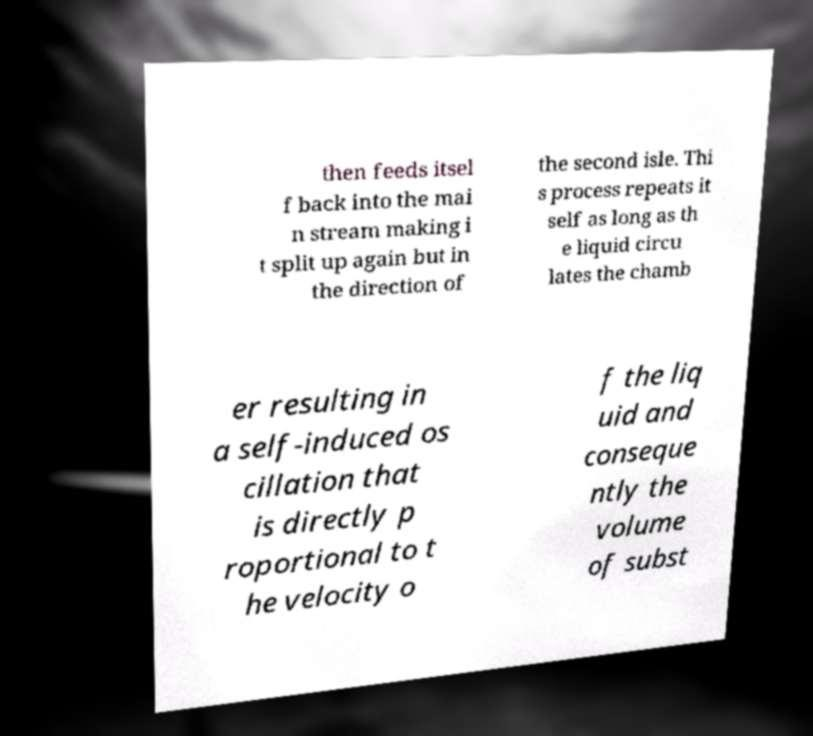What messages or text are displayed in this image? I need them in a readable, typed format. then feeds itsel f back into the mai n stream making i t split up again but in the direction of the second isle. Thi s process repeats it self as long as th e liquid circu lates the chamb er resulting in a self-induced os cillation that is directly p roportional to t he velocity o f the liq uid and conseque ntly the volume of subst 